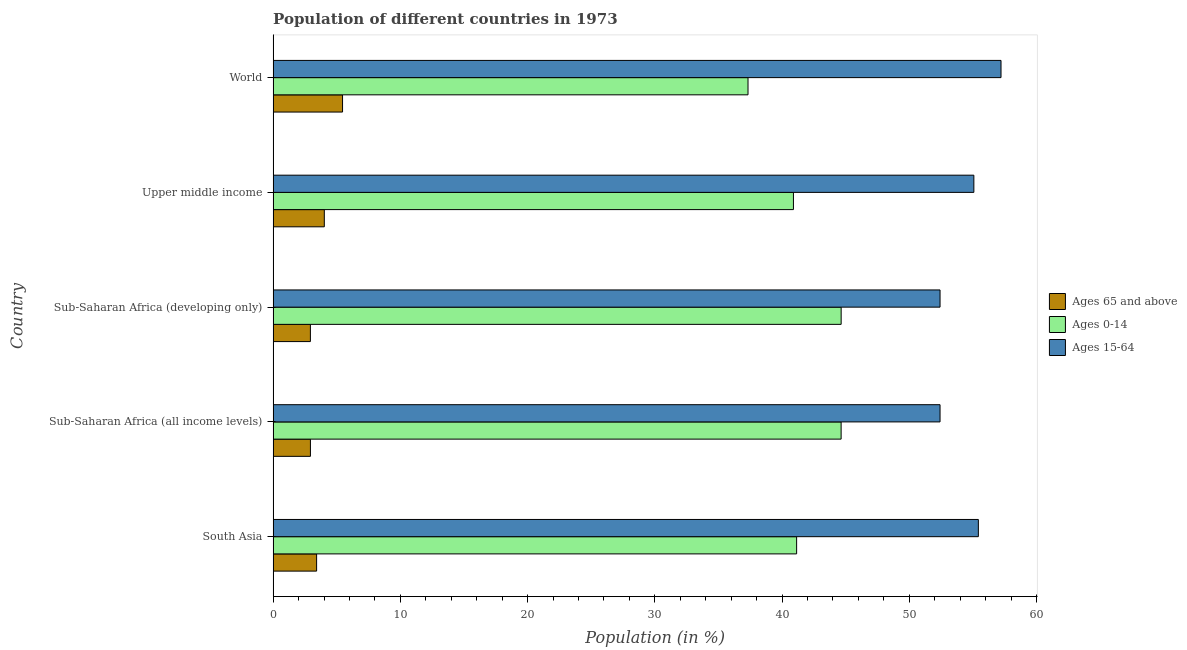How many groups of bars are there?
Ensure brevity in your answer.  5. Are the number of bars on each tick of the Y-axis equal?
Your answer should be compact. Yes. What is the label of the 3rd group of bars from the top?
Your answer should be very brief. Sub-Saharan Africa (developing only). What is the percentage of population within the age-group 15-64 in Upper middle income?
Provide a succinct answer. 55.08. Across all countries, what is the maximum percentage of population within the age-group of 65 and above?
Offer a terse response. 5.46. Across all countries, what is the minimum percentage of population within the age-group 0-14?
Offer a very short reply. 37.33. In which country was the percentage of population within the age-group of 65 and above minimum?
Your response must be concise. Sub-Saharan Africa (developing only). What is the total percentage of population within the age-group of 65 and above in the graph?
Provide a short and direct response. 18.76. What is the difference between the percentage of population within the age-group 0-14 in South Asia and that in World?
Provide a succinct answer. 3.82. What is the difference between the percentage of population within the age-group 0-14 in South Asia and the percentage of population within the age-group 15-64 in Sub-Saharan Africa (developing only)?
Give a very brief answer. -11.27. What is the average percentage of population within the age-group 15-64 per country?
Offer a very short reply. 54.51. What is the difference between the percentage of population within the age-group 15-64 and percentage of population within the age-group of 65 and above in Sub-Saharan Africa (developing only)?
Offer a very short reply. 49.49. In how many countries, is the percentage of population within the age-group of 65 and above greater than 24 %?
Give a very brief answer. 0. What is the ratio of the percentage of population within the age-group of 65 and above in Upper middle income to that in World?
Offer a very short reply. 0.74. What is the difference between the highest and the second highest percentage of population within the age-group 15-64?
Make the answer very short. 1.78. What is the difference between the highest and the lowest percentage of population within the age-group 0-14?
Give a very brief answer. 7.32. In how many countries, is the percentage of population within the age-group of 65 and above greater than the average percentage of population within the age-group of 65 and above taken over all countries?
Your answer should be compact. 2. What does the 3rd bar from the top in Sub-Saharan Africa (all income levels) represents?
Offer a terse response. Ages 65 and above. What does the 2nd bar from the bottom in Upper middle income represents?
Your response must be concise. Ages 0-14. Is it the case that in every country, the sum of the percentage of population within the age-group of 65 and above and percentage of population within the age-group 0-14 is greater than the percentage of population within the age-group 15-64?
Make the answer very short. No. How many bars are there?
Your answer should be very brief. 15. How many countries are there in the graph?
Your answer should be compact. 5. Are the values on the major ticks of X-axis written in scientific E-notation?
Provide a short and direct response. No. Does the graph contain any zero values?
Your answer should be compact. No. What is the title of the graph?
Your answer should be compact. Population of different countries in 1973. Does "Industrial Nitrous Oxide" appear as one of the legend labels in the graph?
Offer a terse response. No. What is the label or title of the X-axis?
Your answer should be very brief. Population (in %). What is the label or title of the Y-axis?
Provide a succinct answer. Country. What is the Population (in %) of Ages 65 and above in South Asia?
Your response must be concise. 3.42. What is the Population (in %) in Ages 0-14 in South Asia?
Ensure brevity in your answer.  41.15. What is the Population (in %) in Ages 15-64 in South Asia?
Make the answer very short. 55.43. What is the Population (in %) of Ages 65 and above in Sub-Saharan Africa (all income levels)?
Keep it short and to the point. 2.93. What is the Population (in %) in Ages 0-14 in Sub-Saharan Africa (all income levels)?
Your answer should be very brief. 44.65. What is the Population (in %) of Ages 15-64 in Sub-Saharan Africa (all income levels)?
Offer a very short reply. 52.42. What is the Population (in %) of Ages 65 and above in Sub-Saharan Africa (developing only)?
Provide a succinct answer. 2.93. What is the Population (in %) in Ages 0-14 in Sub-Saharan Africa (developing only)?
Give a very brief answer. 44.65. What is the Population (in %) of Ages 15-64 in Sub-Saharan Africa (developing only)?
Offer a very short reply. 52.42. What is the Population (in %) in Ages 65 and above in Upper middle income?
Your answer should be compact. 4.02. What is the Population (in %) of Ages 0-14 in Upper middle income?
Provide a short and direct response. 40.9. What is the Population (in %) in Ages 15-64 in Upper middle income?
Keep it short and to the point. 55.08. What is the Population (in %) in Ages 65 and above in World?
Provide a succinct answer. 5.46. What is the Population (in %) of Ages 0-14 in World?
Your response must be concise. 37.33. What is the Population (in %) of Ages 15-64 in World?
Your answer should be very brief. 57.21. Across all countries, what is the maximum Population (in %) in Ages 65 and above?
Keep it short and to the point. 5.46. Across all countries, what is the maximum Population (in %) in Ages 0-14?
Provide a short and direct response. 44.65. Across all countries, what is the maximum Population (in %) of Ages 15-64?
Your response must be concise. 57.21. Across all countries, what is the minimum Population (in %) in Ages 65 and above?
Your answer should be very brief. 2.93. Across all countries, what is the minimum Population (in %) of Ages 0-14?
Offer a terse response. 37.33. Across all countries, what is the minimum Population (in %) in Ages 15-64?
Your answer should be very brief. 52.42. What is the total Population (in %) of Ages 65 and above in the graph?
Your answer should be compact. 18.76. What is the total Population (in %) of Ages 0-14 in the graph?
Offer a very short reply. 208.67. What is the total Population (in %) in Ages 15-64 in the graph?
Your response must be concise. 272.57. What is the difference between the Population (in %) of Ages 65 and above in South Asia and that in Sub-Saharan Africa (all income levels)?
Keep it short and to the point. 0.49. What is the difference between the Population (in %) in Ages 0-14 in South Asia and that in Sub-Saharan Africa (all income levels)?
Keep it short and to the point. -3.5. What is the difference between the Population (in %) in Ages 15-64 in South Asia and that in Sub-Saharan Africa (all income levels)?
Ensure brevity in your answer.  3.01. What is the difference between the Population (in %) of Ages 65 and above in South Asia and that in Sub-Saharan Africa (developing only)?
Offer a terse response. 0.49. What is the difference between the Population (in %) of Ages 0-14 in South Asia and that in Sub-Saharan Africa (developing only)?
Ensure brevity in your answer.  -3.5. What is the difference between the Population (in %) in Ages 15-64 in South Asia and that in Sub-Saharan Africa (developing only)?
Ensure brevity in your answer.  3.01. What is the difference between the Population (in %) of Ages 65 and above in South Asia and that in Upper middle income?
Your answer should be very brief. -0.61. What is the difference between the Population (in %) of Ages 0-14 in South Asia and that in Upper middle income?
Your answer should be compact. 0.25. What is the difference between the Population (in %) of Ages 15-64 in South Asia and that in Upper middle income?
Provide a succinct answer. 0.35. What is the difference between the Population (in %) in Ages 65 and above in South Asia and that in World?
Give a very brief answer. -2.04. What is the difference between the Population (in %) of Ages 0-14 in South Asia and that in World?
Offer a very short reply. 3.82. What is the difference between the Population (in %) in Ages 15-64 in South Asia and that in World?
Keep it short and to the point. -1.78. What is the difference between the Population (in %) of Ages 65 and above in Sub-Saharan Africa (all income levels) and that in Sub-Saharan Africa (developing only)?
Make the answer very short. 0. What is the difference between the Population (in %) of Ages 0-14 in Sub-Saharan Africa (all income levels) and that in Sub-Saharan Africa (developing only)?
Give a very brief answer. -0. What is the difference between the Population (in %) in Ages 15-64 in Sub-Saharan Africa (all income levels) and that in Sub-Saharan Africa (developing only)?
Keep it short and to the point. -0. What is the difference between the Population (in %) in Ages 65 and above in Sub-Saharan Africa (all income levels) and that in Upper middle income?
Keep it short and to the point. -1.09. What is the difference between the Population (in %) in Ages 0-14 in Sub-Saharan Africa (all income levels) and that in Upper middle income?
Your answer should be very brief. 3.75. What is the difference between the Population (in %) of Ages 15-64 in Sub-Saharan Africa (all income levels) and that in Upper middle income?
Offer a terse response. -2.66. What is the difference between the Population (in %) of Ages 65 and above in Sub-Saharan Africa (all income levels) and that in World?
Offer a terse response. -2.53. What is the difference between the Population (in %) of Ages 0-14 in Sub-Saharan Africa (all income levels) and that in World?
Your answer should be very brief. 7.32. What is the difference between the Population (in %) in Ages 15-64 in Sub-Saharan Africa (all income levels) and that in World?
Offer a terse response. -4.79. What is the difference between the Population (in %) of Ages 65 and above in Sub-Saharan Africa (developing only) and that in Upper middle income?
Provide a short and direct response. -1.09. What is the difference between the Population (in %) of Ages 0-14 in Sub-Saharan Africa (developing only) and that in Upper middle income?
Your response must be concise. 3.75. What is the difference between the Population (in %) in Ages 15-64 in Sub-Saharan Africa (developing only) and that in Upper middle income?
Keep it short and to the point. -2.66. What is the difference between the Population (in %) of Ages 65 and above in Sub-Saharan Africa (developing only) and that in World?
Your answer should be very brief. -2.53. What is the difference between the Population (in %) of Ages 0-14 in Sub-Saharan Africa (developing only) and that in World?
Your answer should be compact. 7.32. What is the difference between the Population (in %) in Ages 15-64 in Sub-Saharan Africa (developing only) and that in World?
Offer a very short reply. -4.79. What is the difference between the Population (in %) in Ages 65 and above in Upper middle income and that in World?
Your answer should be compact. -1.43. What is the difference between the Population (in %) in Ages 0-14 in Upper middle income and that in World?
Ensure brevity in your answer.  3.57. What is the difference between the Population (in %) of Ages 15-64 in Upper middle income and that in World?
Your response must be concise. -2.14. What is the difference between the Population (in %) in Ages 65 and above in South Asia and the Population (in %) in Ages 0-14 in Sub-Saharan Africa (all income levels)?
Offer a terse response. -41.23. What is the difference between the Population (in %) of Ages 65 and above in South Asia and the Population (in %) of Ages 15-64 in Sub-Saharan Africa (all income levels)?
Provide a succinct answer. -49. What is the difference between the Population (in %) of Ages 0-14 in South Asia and the Population (in %) of Ages 15-64 in Sub-Saharan Africa (all income levels)?
Your answer should be very brief. -11.27. What is the difference between the Population (in %) in Ages 65 and above in South Asia and the Population (in %) in Ages 0-14 in Sub-Saharan Africa (developing only)?
Ensure brevity in your answer.  -41.23. What is the difference between the Population (in %) in Ages 65 and above in South Asia and the Population (in %) in Ages 15-64 in Sub-Saharan Africa (developing only)?
Provide a succinct answer. -49. What is the difference between the Population (in %) in Ages 0-14 in South Asia and the Population (in %) in Ages 15-64 in Sub-Saharan Africa (developing only)?
Give a very brief answer. -11.27. What is the difference between the Population (in %) in Ages 65 and above in South Asia and the Population (in %) in Ages 0-14 in Upper middle income?
Provide a short and direct response. -37.48. What is the difference between the Population (in %) of Ages 65 and above in South Asia and the Population (in %) of Ages 15-64 in Upper middle income?
Your answer should be very brief. -51.66. What is the difference between the Population (in %) in Ages 0-14 in South Asia and the Population (in %) in Ages 15-64 in Upper middle income?
Provide a short and direct response. -13.93. What is the difference between the Population (in %) of Ages 65 and above in South Asia and the Population (in %) of Ages 0-14 in World?
Give a very brief answer. -33.91. What is the difference between the Population (in %) of Ages 65 and above in South Asia and the Population (in %) of Ages 15-64 in World?
Offer a terse response. -53.8. What is the difference between the Population (in %) in Ages 0-14 in South Asia and the Population (in %) in Ages 15-64 in World?
Keep it short and to the point. -16.07. What is the difference between the Population (in %) in Ages 65 and above in Sub-Saharan Africa (all income levels) and the Population (in %) in Ages 0-14 in Sub-Saharan Africa (developing only)?
Provide a short and direct response. -41.72. What is the difference between the Population (in %) of Ages 65 and above in Sub-Saharan Africa (all income levels) and the Population (in %) of Ages 15-64 in Sub-Saharan Africa (developing only)?
Offer a very short reply. -49.49. What is the difference between the Population (in %) in Ages 0-14 in Sub-Saharan Africa (all income levels) and the Population (in %) in Ages 15-64 in Sub-Saharan Africa (developing only)?
Provide a succinct answer. -7.78. What is the difference between the Population (in %) of Ages 65 and above in Sub-Saharan Africa (all income levels) and the Population (in %) of Ages 0-14 in Upper middle income?
Provide a short and direct response. -37.97. What is the difference between the Population (in %) of Ages 65 and above in Sub-Saharan Africa (all income levels) and the Population (in %) of Ages 15-64 in Upper middle income?
Provide a succinct answer. -52.15. What is the difference between the Population (in %) of Ages 0-14 in Sub-Saharan Africa (all income levels) and the Population (in %) of Ages 15-64 in Upper middle income?
Ensure brevity in your answer.  -10.43. What is the difference between the Population (in %) of Ages 65 and above in Sub-Saharan Africa (all income levels) and the Population (in %) of Ages 0-14 in World?
Your answer should be very brief. -34.4. What is the difference between the Population (in %) of Ages 65 and above in Sub-Saharan Africa (all income levels) and the Population (in %) of Ages 15-64 in World?
Your answer should be very brief. -54.28. What is the difference between the Population (in %) in Ages 0-14 in Sub-Saharan Africa (all income levels) and the Population (in %) in Ages 15-64 in World?
Offer a very short reply. -12.57. What is the difference between the Population (in %) in Ages 65 and above in Sub-Saharan Africa (developing only) and the Population (in %) in Ages 0-14 in Upper middle income?
Offer a very short reply. -37.97. What is the difference between the Population (in %) of Ages 65 and above in Sub-Saharan Africa (developing only) and the Population (in %) of Ages 15-64 in Upper middle income?
Provide a short and direct response. -52.15. What is the difference between the Population (in %) of Ages 0-14 in Sub-Saharan Africa (developing only) and the Population (in %) of Ages 15-64 in Upper middle income?
Your response must be concise. -10.43. What is the difference between the Population (in %) of Ages 65 and above in Sub-Saharan Africa (developing only) and the Population (in %) of Ages 0-14 in World?
Ensure brevity in your answer.  -34.4. What is the difference between the Population (in %) of Ages 65 and above in Sub-Saharan Africa (developing only) and the Population (in %) of Ages 15-64 in World?
Offer a terse response. -54.28. What is the difference between the Population (in %) in Ages 0-14 in Sub-Saharan Africa (developing only) and the Population (in %) in Ages 15-64 in World?
Offer a very short reply. -12.57. What is the difference between the Population (in %) in Ages 65 and above in Upper middle income and the Population (in %) in Ages 0-14 in World?
Your answer should be compact. -33.3. What is the difference between the Population (in %) in Ages 65 and above in Upper middle income and the Population (in %) in Ages 15-64 in World?
Your response must be concise. -53.19. What is the difference between the Population (in %) of Ages 0-14 in Upper middle income and the Population (in %) of Ages 15-64 in World?
Offer a very short reply. -16.32. What is the average Population (in %) in Ages 65 and above per country?
Your response must be concise. 3.75. What is the average Population (in %) of Ages 0-14 per country?
Offer a very short reply. 41.73. What is the average Population (in %) in Ages 15-64 per country?
Offer a terse response. 54.51. What is the difference between the Population (in %) in Ages 65 and above and Population (in %) in Ages 0-14 in South Asia?
Ensure brevity in your answer.  -37.73. What is the difference between the Population (in %) of Ages 65 and above and Population (in %) of Ages 15-64 in South Asia?
Your response must be concise. -52.02. What is the difference between the Population (in %) of Ages 0-14 and Population (in %) of Ages 15-64 in South Asia?
Offer a terse response. -14.28. What is the difference between the Population (in %) in Ages 65 and above and Population (in %) in Ages 0-14 in Sub-Saharan Africa (all income levels)?
Give a very brief answer. -41.71. What is the difference between the Population (in %) of Ages 65 and above and Population (in %) of Ages 15-64 in Sub-Saharan Africa (all income levels)?
Give a very brief answer. -49.49. What is the difference between the Population (in %) of Ages 0-14 and Population (in %) of Ages 15-64 in Sub-Saharan Africa (all income levels)?
Make the answer very short. -7.78. What is the difference between the Population (in %) of Ages 65 and above and Population (in %) of Ages 0-14 in Sub-Saharan Africa (developing only)?
Offer a terse response. -41.72. What is the difference between the Population (in %) of Ages 65 and above and Population (in %) of Ages 15-64 in Sub-Saharan Africa (developing only)?
Offer a terse response. -49.49. What is the difference between the Population (in %) in Ages 0-14 and Population (in %) in Ages 15-64 in Sub-Saharan Africa (developing only)?
Your answer should be compact. -7.77. What is the difference between the Population (in %) of Ages 65 and above and Population (in %) of Ages 0-14 in Upper middle income?
Offer a very short reply. -36.87. What is the difference between the Population (in %) in Ages 65 and above and Population (in %) in Ages 15-64 in Upper middle income?
Ensure brevity in your answer.  -51.06. What is the difference between the Population (in %) of Ages 0-14 and Population (in %) of Ages 15-64 in Upper middle income?
Provide a short and direct response. -14.18. What is the difference between the Population (in %) of Ages 65 and above and Population (in %) of Ages 0-14 in World?
Keep it short and to the point. -31.87. What is the difference between the Population (in %) of Ages 65 and above and Population (in %) of Ages 15-64 in World?
Your response must be concise. -51.76. What is the difference between the Population (in %) of Ages 0-14 and Population (in %) of Ages 15-64 in World?
Offer a terse response. -19.89. What is the ratio of the Population (in %) in Ages 65 and above in South Asia to that in Sub-Saharan Africa (all income levels)?
Your answer should be very brief. 1.17. What is the ratio of the Population (in %) in Ages 0-14 in South Asia to that in Sub-Saharan Africa (all income levels)?
Your answer should be compact. 0.92. What is the ratio of the Population (in %) in Ages 15-64 in South Asia to that in Sub-Saharan Africa (all income levels)?
Offer a very short reply. 1.06. What is the ratio of the Population (in %) of Ages 0-14 in South Asia to that in Sub-Saharan Africa (developing only)?
Your answer should be compact. 0.92. What is the ratio of the Population (in %) in Ages 15-64 in South Asia to that in Sub-Saharan Africa (developing only)?
Make the answer very short. 1.06. What is the ratio of the Population (in %) in Ages 65 and above in South Asia to that in Upper middle income?
Make the answer very short. 0.85. What is the ratio of the Population (in %) in Ages 15-64 in South Asia to that in Upper middle income?
Provide a short and direct response. 1.01. What is the ratio of the Population (in %) in Ages 65 and above in South Asia to that in World?
Keep it short and to the point. 0.63. What is the ratio of the Population (in %) of Ages 0-14 in South Asia to that in World?
Your answer should be very brief. 1.1. What is the ratio of the Population (in %) of Ages 15-64 in South Asia to that in World?
Your response must be concise. 0.97. What is the ratio of the Population (in %) in Ages 15-64 in Sub-Saharan Africa (all income levels) to that in Sub-Saharan Africa (developing only)?
Provide a succinct answer. 1. What is the ratio of the Population (in %) in Ages 65 and above in Sub-Saharan Africa (all income levels) to that in Upper middle income?
Provide a short and direct response. 0.73. What is the ratio of the Population (in %) in Ages 0-14 in Sub-Saharan Africa (all income levels) to that in Upper middle income?
Offer a terse response. 1.09. What is the ratio of the Population (in %) of Ages 15-64 in Sub-Saharan Africa (all income levels) to that in Upper middle income?
Make the answer very short. 0.95. What is the ratio of the Population (in %) of Ages 65 and above in Sub-Saharan Africa (all income levels) to that in World?
Provide a succinct answer. 0.54. What is the ratio of the Population (in %) of Ages 0-14 in Sub-Saharan Africa (all income levels) to that in World?
Your answer should be compact. 1.2. What is the ratio of the Population (in %) of Ages 15-64 in Sub-Saharan Africa (all income levels) to that in World?
Provide a short and direct response. 0.92. What is the ratio of the Population (in %) of Ages 65 and above in Sub-Saharan Africa (developing only) to that in Upper middle income?
Provide a succinct answer. 0.73. What is the ratio of the Population (in %) in Ages 0-14 in Sub-Saharan Africa (developing only) to that in Upper middle income?
Make the answer very short. 1.09. What is the ratio of the Population (in %) of Ages 15-64 in Sub-Saharan Africa (developing only) to that in Upper middle income?
Give a very brief answer. 0.95. What is the ratio of the Population (in %) of Ages 65 and above in Sub-Saharan Africa (developing only) to that in World?
Your answer should be very brief. 0.54. What is the ratio of the Population (in %) in Ages 0-14 in Sub-Saharan Africa (developing only) to that in World?
Offer a very short reply. 1.2. What is the ratio of the Population (in %) in Ages 15-64 in Sub-Saharan Africa (developing only) to that in World?
Provide a succinct answer. 0.92. What is the ratio of the Population (in %) in Ages 65 and above in Upper middle income to that in World?
Ensure brevity in your answer.  0.74. What is the ratio of the Population (in %) of Ages 0-14 in Upper middle income to that in World?
Your answer should be very brief. 1.1. What is the ratio of the Population (in %) of Ages 15-64 in Upper middle income to that in World?
Offer a terse response. 0.96. What is the difference between the highest and the second highest Population (in %) in Ages 65 and above?
Your response must be concise. 1.43. What is the difference between the highest and the second highest Population (in %) in Ages 0-14?
Make the answer very short. 0. What is the difference between the highest and the second highest Population (in %) in Ages 15-64?
Keep it short and to the point. 1.78. What is the difference between the highest and the lowest Population (in %) of Ages 65 and above?
Provide a succinct answer. 2.53. What is the difference between the highest and the lowest Population (in %) in Ages 0-14?
Provide a short and direct response. 7.32. What is the difference between the highest and the lowest Population (in %) of Ages 15-64?
Offer a very short reply. 4.79. 